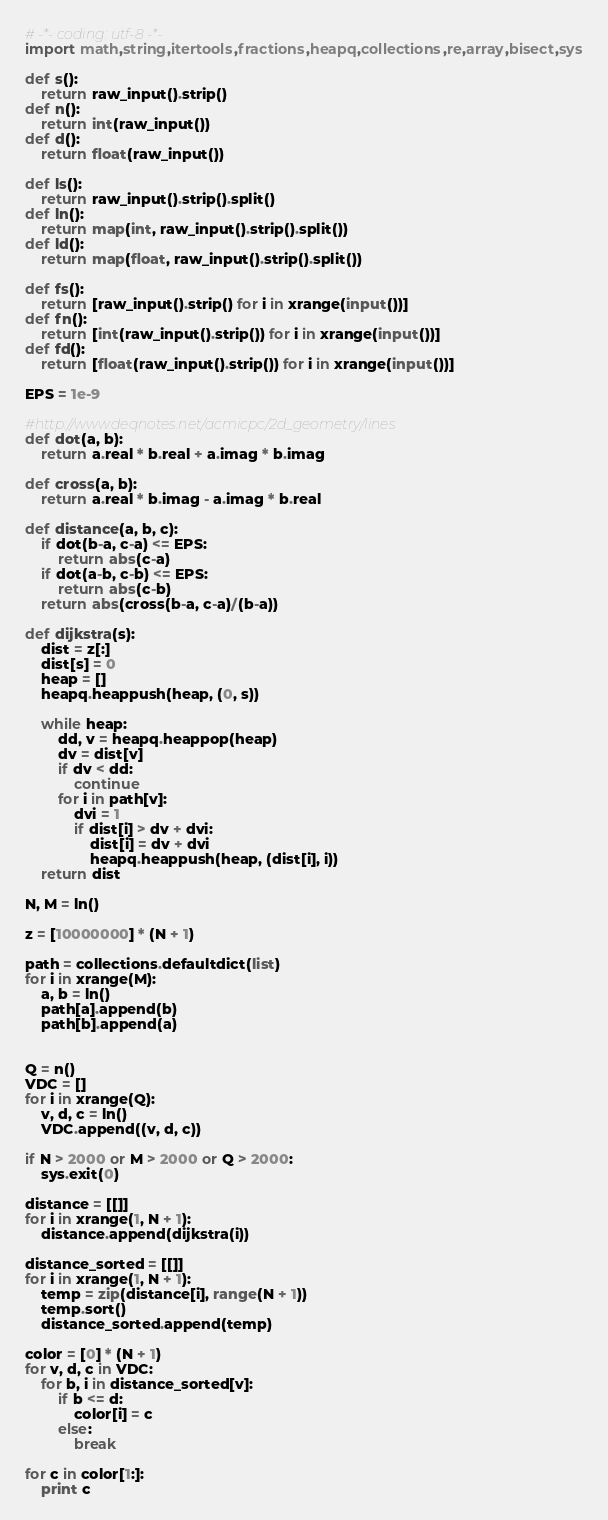<code> <loc_0><loc_0><loc_500><loc_500><_Python_># -*- coding: utf-8 -*-
import math,string,itertools,fractions,heapq,collections,re,array,bisect,sys

def s():
    return raw_input().strip()
def n():
    return int(raw_input())
def d():
    return float(raw_input())

def ls():
    return raw_input().strip().split()
def ln():
    return map(int, raw_input().strip().split())
def ld():
    return map(float, raw_input().strip().split())

def fs():
    return [raw_input().strip() for i in xrange(input())]
def fn():
    return [int(raw_input().strip()) for i in xrange(input())]
def fd():
    return [float(raw_input().strip()) for i in xrange(input())]

EPS = 1e-9

#http://www.deqnotes.net/acmicpc/2d_geometry/lines
def dot(a, b):
    return a.real * b.real + a.imag * b.imag

def cross(a, b):
    return a.real * b.imag - a.imag * b.real

def distance(a, b, c):
    if dot(b-a, c-a) <= EPS:
        return abs(c-a)
    if dot(a-b, c-b) <= EPS:
        return abs(c-b)
    return abs(cross(b-a, c-a)/(b-a))

def dijkstra(s):
    dist = z[:]
    dist[s] = 0
    heap = []
    heapq.heappush(heap, (0, s))
    
    while heap:
        dd, v = heapq.heappop(heap)
        dv = dist[v]
        if dv < dd:
            continue
        for i in path[v]:
            dvi = 1
            if dist[i] > dv + dvi:
                dist[i] = dv + dvi
                heapq.heappush(heap, (dist[i], i))
    return dist

N, M = ln()

z = [10000000] * (N + 1)

path = collections.defaultdict(list)
for i in xrange(M):
    a, b = ln()
    path[a].append(b)
    path[b].append(a)


Q = n()
VDC = []
for i in xrange(Q):
    v, d, c = ln()
    VDC.append((v, d, c))

if N > 2000 or M > 2000 or Q > 2000:
    sys.exit(0)

distance = [[]]
for i in xrange(1, N + 1):
    distance.append(dijkstra(i))

distance_sorted = [[]]
for i in xrange(1, N + 1):
    temp = zip(distance[i], range(N + 1))
    temp.sort()
    distance_sorted.append(temp)

color = [0] * (N + 1)
for v, d, c in VDC:
    for b, i in distance_sorted[v]:
        if b <= d:
            color[i] = c
        else:
            break

for c in color[1:]:
    print c
</code> 